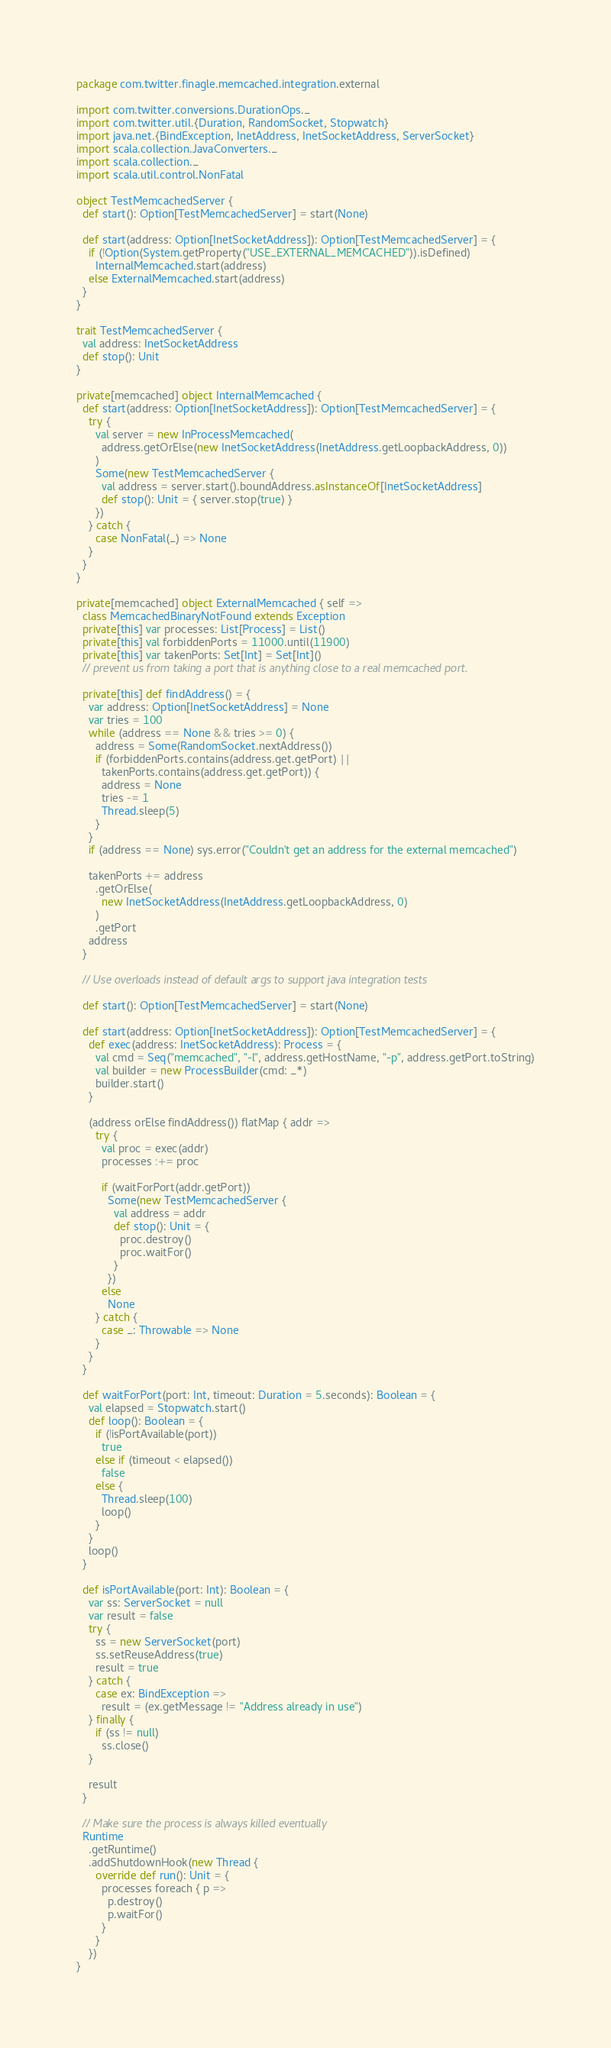Convert code to text. <code><loc_0><loc_0><loc_500><loc_500><_Scala_>package com.twitter.finagle.memcached.integration.external

import com.twitter.conversions.DurationOps._
import com.twitter.util.{Duration, RandomSocket, Stopwatch}
import java.net.{BindException, InetAddress, InetSocketAddress, ServerSocket}
import scala.collection.JavaConverters._
import scala.collection._
import scala.util.control.NonFatal

object TestMemcachedServer {
  def start(): Option[TestMemcachedServer] = start(None)

  def start(address: Option[InetSocketAddress]): Option[TestMemcachedServer] = {
    if (!Option(System.getProperty("USE_EXTERNAL_MEMCACHED")).isDefined)
      InternalMemcached.start(address)
    else ExternalMemcached.start(address)
  }
}

trait TestMemcachedServer {
  val address: InetSocketAddress
  def stop(): Unit
}

private[memcached] object InternalMemcached {
  def start(address: Option[InetSocketAddress]): Option[TestMemcachedServer] = {
    try {
      val server = new InProcessMemcached(
        address.getOrElse(new InetSocketAddress(InetAddress.getLoopbackAddress, 0))
      )
      Some(new TestMemcachedServer {
        val address = server.start().boundAddress.asInstanceOf[InetSocketAddress]
        def stop(): Unit = { server.stop(true) }
      })
    } catch {
      case NonFatal(_) => None
    }
  }
}

private[memcached] object ExternalMemcached { self =>
  class MemcachedBinaryNotFound extends Exception
  private[this] var processes: List[Process] = List()
  private[this] val forbiddenPorts = 11000.until(11900)
  private[this] var takenPorts: Set[Int] = Set[Int]()
  // prevent us from taking a port that is anything close to a real memcached port.

  private[this] def findAddress() = {
    var address: Option[InetSocketAddress] = None
    var tries = 100
    while (address == None && tries >= 0) {
      address = Some(RandomSocket.nextAddress())
      if (forbiddenPorts.contains(address.get.getPort) ||
        takenPorts.contains(address.get.getPort)) {
        address = None
        tries -= 1
        Thread.sleep(5)
      }
    }
    if (address == None) sys.error("Couldn't get an address for the external memcached")

    takenPorts += address
      .getOrElse(
        new InetSocketAddress(InetAddress.getLoopbackAddress, 0)
      )
      .getPort
    address
  }

  // Use overloads instead of default args to support java integration tests

  def start(): Option[TestMemcachedServer] = start(None)

  def start(address: Option[InetSocketAddress]): Option[TestMemcachedServer] = {
    def exec(address: InetSocketAddress): Process = {
      val cmd = Seq("memcached", "-l", address.getHostName, "-p", address.getPort.toString)
      val builder = new ProcessBuilder(cmd: _*)
      builder.start()
    }

    (address orElse findAddress()) flatMap { addr =>
      try {
        val proc = exec(addr)
        processes :+= proc

        if (waitForPort(addr.getPort))
          Some(new TestMemcachedServer {
            val address = addr
            def stop(): Unit = {
              proc.destroy()
              proc.waitFor()
            }
          })
        else
          None
      } catch {
        case _: Throwable => None
      }
    }
  }

  def waitForPort(port: Int, timeout: Duration = 5.seconds): Boolean = {
    val elapsed = Stopwatch.start()
    def loop(): Boolean = {
      if (!isPortAvailable(port))
        true
      else if (timeout < elapsed())
        false
      else {
        Thread.sleep(100)
        loop()
      }
    }
    loop()
  }

  def isPortAvailable(port: Int): Boolean = {
    var ss: ServerSocket = null
    var result = false
    try {
      ss = new ServerSocket(port)
      ss.setReuseAddress(true)
      result = true
    } catch {
      case ex: BindException =>
        result = (ex.getMessage != "Address already in use")
    } finally {
      if (ss != null)
        ss.close()
    }

    result
  }

  // Make sure the process is always killed eventually
  Runtime
    .getRuntime()
    .addShutdownHook(new Thread {
      override def run(): Unit = {
        processes foreach { p =>
          p.destroy()
          p.waitFor()
        }
      }
    })
}
</code> 